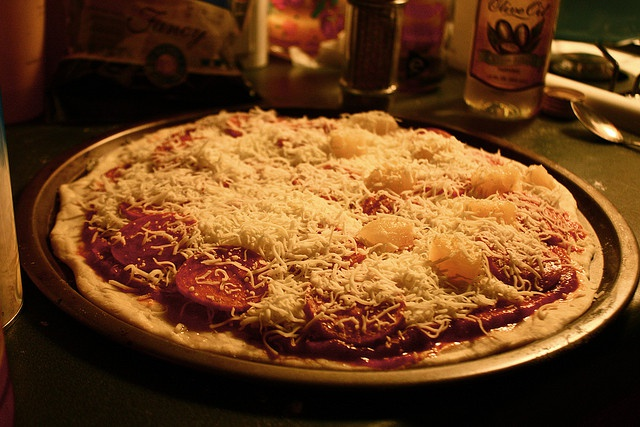Describe the objects in this image and their specific colors. I can see pizza in maroon, orange, and red tones, bottle in maroon, black, and brown tones, bottle in maroon, black, and brown tones, bottle in maroon, black, and orange tones, and spoon in maroon, black, orange, and olive tones in this image. 